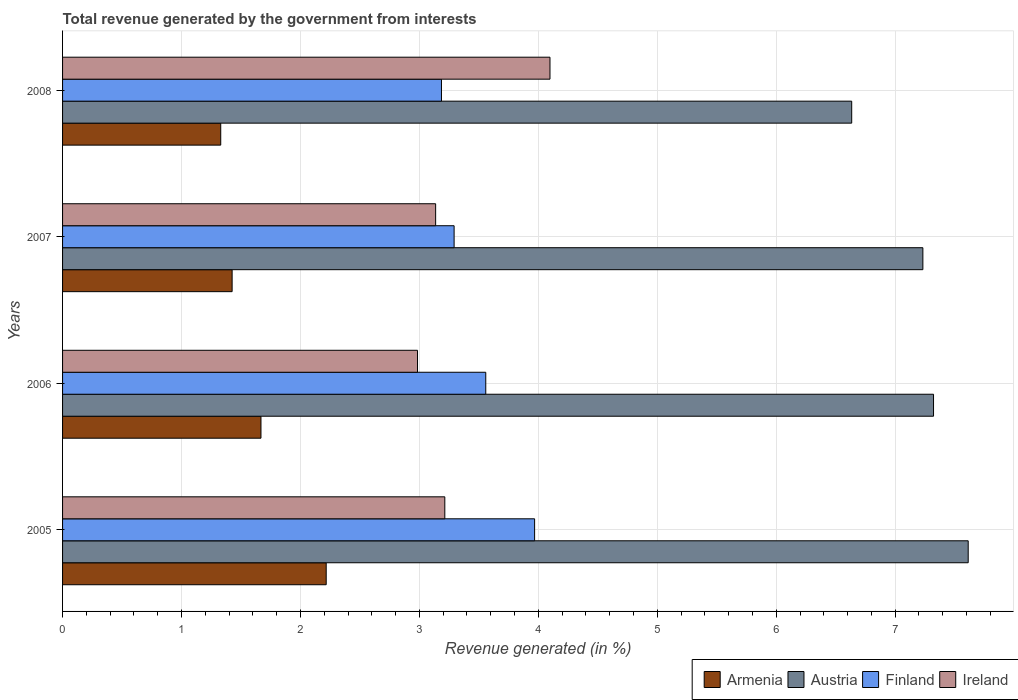How many different coloured bars are there?
Provide a succinct answer. 4. How many groups of bars are there?
Your response must be concise. 4. Are the number of bars per tick equal to the number of legend labels?
Provide a succinct answer. Yes. Are the number of bars on each tick of the Y-axis equal?
Give a very brief answer. Yes. What is the total revenue generated in Ireland in 2007?
Your response must be concise. 3.14. Across all years, what is the maximum total revenue generated in Ireland?
Keep it short and to the point. 4.1. Across all years, what is the minimum total revenue generated in Armenia?
Make the answer very short. 1.33. What is the total total revenue generated in Ireland in the graph?
Offer a very short reply. 13.43. What is the difference between the total revenue generated in Armenia in 2006 and that in 2008?
Give a very brief answer. 0.34. What is the difference between the total revenue generated in Armenia in 2005 and the total revenue generated in Finland in 2008?
Your answer should be very brief. -0.97. What is the average total revenue generated in Ireland per year?
Your response must be concise. 3.36. In the year 2007, what is the difference between the total revenue generated in Finland and total revenue generated in Ireland?
Offer a very short reply. 0.16. What is the ratio of the total revenue generated in Austria in 2006 to that in 2008?
Your response must be concise. 1.1. Is the total revenue generated in Finland in 2007 less than that in 2008?
Offer a terse response. No. Is the difference between the total revenue generated in Finland in 2005 and 2006 greater than the difference between the total revenue generated in Ireland in 2005 and 2006?
Your answer should be compact. Yes. What is the difference between the highest and the second highest total revenue generated in Austria?
Provide a short and direct response. 0.29. What is the difference between the highest and the lowest total revenue generated in Finland?
Provide a succinct answer. 0.78. In how many years, is the total revenue generated in Austria greater than the average total revenue generated in Austria taken over all years?
Keep it short and to the point. 3. What does the 3rd bar from the top in 2006 represents?
Give a very brief answer. Austria. What does the 4th bar from the bottom in 2005 represents?
Give a very brief answer. Ireland. How many years are there in the graph?
Your answer should be compact. 4. What is the difference between two consecutive major ticks on the X-axis?
Offer a terse response. 1. Does the graph contain any zero values?
Your answer should be compact. No. Where does the legend appear in the graph?
Offer a terse response. Bottom right. What is the title of the graph?
Keep it short and to the point. Total revenue generated by the government from interests. What is the label or title of the X-axis?
Keep it short and to the point. Revenue generated (in %). What is the Revenue generated (in %) in Armenia in 2005?
Your answer should be very brief. 2.22. What is the Revenue generated (in %) of Austria in 2005?
Keep it short and to the point. 7.61. What is the Revenue generated (in %) in Finland in 2005?
Keep it short and to the point. 3.97. What is the Revenue generated (in %) in Ireland in 2005?
Your response must be concise. 3.21. What is the Revenue generated (in %) in Armenia in 2006?
Offer a terse response. 1.67. What is the Revenue generated (in %) in Austria in 2006?
Give a very brief answer. 7.32. What is the Revenue generated (in %) in Finland in 2006?
Provide a short and direct response. 3.56. What is the Revenue generated (in %) of Ireland in 2006?
Ensure brevity in your answer.  2.98. What is the Revenue generated (in %) in Armenia in 2007?
Your answer should be very brief. 1.43. What is the Revenue generated (in %) in Austria in 2007?
Give a very brief answer. 7.23. What is the Revenue generated (in %) in Finland in 2007?
Keep it short and to the point. 3.29. What is the Revenue generated (in %) in Ireland in 2007?
Ensure brevity in your answer.  3.14. What is the Revenue generated (in %) in Armenia in 2008?
Your answer should be very brief. 1.33. What is the Revenue generated (in %) of Austria in 2008?
Make the answer very short. 6.63. What is the Revenue generated (in %) in Finland in 2008?
Provide a short and direct response. 3.19. What is the Revenue generated (in %) in Ireland in 2008?
Keep it short and to the point. 4.1. Across all years, what is the maximum Revenue generated (in %) of Armenia?
Provide a succinct answer. 2.22. Across all years, what is the maximum Revenue generated (in %) of Austria?
Your response must be concise. 7.61. Across all years, what is the maximum Revenue generated (in %) of Finland?
Your response must be concise. 3.97. Across all years, what is the maximum Revenue generated (in %) of Ireland?
Keep it short and to the point. 4.1. Across all years, what is the minimum Revenue generated (in %) of Armenia?
Keep it short and to the point. 1.33. Across all years, what is the minimum Revenue generated (in %) of Austria?
Ensure brevity in your answer.  6.63. Across all years, what is the minimum Revenue generated (in %) in Finland?
Offer a very short reply. 3.19. Across all years, what is the minimum Revenue generated (in %) in Ireland?
Offer a very short reply. 2.98. What is the total Revenue generated (in %) of Armenia in the graph?
Offer a very short reply. 6.64. What is the total Revenue generated (in %) in Austria in the graph?
Your response must be concise. 28.8. What is the total Revenue generated (in %) in Finland in the graph?
Keep it short and to the point. 14. What is the total Revenue generated (in %) of Ireland in the graph?
Keep it short and to the point. 13.43. What is the difference between the Revenue generated (in %) of Armenia in 2005 and that in 2006?
Keep it short and to the point. 0.55. What is the difference between the Revenue generated (in %) of Austria in 2005 and that in 2006?
Provide a succinct answer. 0.29. What is the difference between the Revenue generated (in %) of Finland in 2005 and that in 2006?
Your response must be concise. 0.41. What is the difference between the Revenue generated (in %) in Ireland in 2005 and that in 2006?
Provide a short and direct response. 0.23. What is the difference between the Revenue generated (in %) of Armenia in 2005 and that in 2007?
Offer a very short reply. 0.79. What is the difference between the Revenue generated (in %) of Austria in 2005 and that in 2007?
Provide a succinct answer. 0.38. What is the difference between the Revenue generated (in %) in Finland in 2005 and that in 2007?
Ensure brevity in your answer.  0.68. What is the difference between the Revenue generated (in %) of Ireland in 2005 and that in 2007?
Your response must be concise. 0.08. What is the difference between the Revenue generated (in %) in Armenia in 2005 and that in 2008?
Your answer should be compact. 0.89. What is the difference between the Revenue generated (in %) in Austria in 2005 and that in 2008?
Your answer should be compact. 0.98. What is the difference between the Revenue generated (in %) of Finland in 2005 and that in 2008?
Offer a very short reply. 0.78. What is the difference between the Revenue generated (in %) of Ireland in 2005 and that in 2008?
Offer a very short reply. -0.88. What is the difference between the Revenue generated (in %) of Armenia in 2006 and that in 2007?
Make the answer very short. 0.24. What is the difference between the Revenue generated (in %) of Austria in 2006 and that in 2007?
Your response must be concise. 0.09. What is the difference between the Revenue generated (in %) in Finland in 2006 and that in 2007?
Provide a succinct answer. 0.27. What is the difference between the Revenue generated (in %) in Ireland in 2006 and that in 2007?
Your answer should be very brief. -0.15. What is the difference between the Revenue generated (in %) in Armenia in 2006 and that in 2008?
Offer a terse response. 0.34. What is the difference between the Revenue generated (in %) in Austria in 2006 and that in 2008?
Your answer should be very brief. 0.69. What is the difference between the Revenue generated (in %) in Finland in 2006 and that in 2008?
Offer a very short reply. 0.37. What is the difference between the Revenue generated (in %) in Ireland in 2006 and that in 2008?
Your response must be concise. -1.11. What is the difference between the Revenue generated (in %) of Armenia in 2007 and that in 2008?
Keep it short and to the point. 0.1. What is the difference between the Revenue generated (in %) in Austria in 2007 and that in 2008?
Your answer should be compact. 0.6. What is the difference between the Revenue generated (in %) of Finland in 2007 and that in 2008?
Offer a very short reply. 0.11. What is the difference between the Revenue generated (in %) of Ireland in 2007 and that in 2008?
Ensure brevity in your answer.  -0.96. What is the difference between the Revenue generated (in %) of Armenia in 2005 and the Revenue generated (in %) of Austria in 2006?
Your response must be concise. -5.11. What is the difference between the Revenue generated (in %) of Armenia in 2005 and the Revenue generated (in %) of Finland in 2006?
Keep it short and to the point. -1.34. What is the difference between the Revenue generated (in %) in Armenia in 2005 and the Revenue generated (in %) in Ireland in 2006?
Keep it short and to the point. -0.77. What is the difference between the Revenue generated (in %) in Austria in 2005 and the Revenue generated (in %) in Finland in 2006?
Give a very brief answer. 4.06. What is the difference between the Revenue generated (in %) in Austria in 2005 and the Revenue generated (in %) in Ireland in 2006?
Your answer should be compact. 4.63. What is the difference between the Revenue generated (in %) in Finland in 2005 and the Revenue generated (in %) in Ireland in 2006?
Make the answer very short. 0.98. What is the difference between the Revenue generated (in %) of Armenia in 2005 and the Revenue generated (in %) of Austria in 2007?
Give a very brief answer. -5.02. What is the difference between the Revenue generated (in %) in Armenia in 2005 and the Revenue generated (in %) in Finland in 2007?
Provide a short and direct response. -1.08. What is the difference between the Revenue generated (in %) in Armenia in 2005 and the Revenue generated (in %) in Ireland in 2007?
Keep it short and to the point. -0.92. What is the difference between the Revenue generated (in %) of Austria in 2005 and the Revenue generated (in %) of Finland in 2007?
Keep it short and to the point. 4.32. What is the difference between the Revenue generated (in %) of Austria in 2005 and the Revenue generated (in %) of Ireland in 2007?
Your answer should be compact. 4.48. What is the difference between the Revenue generated (in %) of Finland in 2005 and the Revenue generated (in %) of Ireland in 2007?
Offer a very short reply. 0.83. What is the difference between the Revenue generated (in %) of Armenia in 2005 and the Revenue generated (in %) of Austria in 2008?
Make the answer very short. -4.42. What is the difference between the Revenue generated (in %) in Armenia in 2005 and the Revenue generated (in %) in Finland in 2008?
Your answer should be compact. -0.97. What is the difference between the Revenue generated (in %) in Armenia in 2005 and the Revenue generated (in %) in Ireland in 2008?
Offer a terse response. -1.88. What is the difference between the Revenue generated (in %) of Austria in 2005 and the Revenue generated (in %) of Finland in 2008?
Offer a terse response. 4.43. What is the difference between the Revenue generated (in %) of Austria in 2005 and the Revenue generated (in %) of Ireland in 2008?
Offer a very short reply. 3.52. What is the difference between the Revenue generated (in %) of Finland in 2005 and the Revenue generated (in %) of Ireland in 2008?
Make the answer very short. -0.13. What is the difference between the Revenue generated (in %) in Armenia in 2006 and the Revenue generated (in %) in Austria in 2007?
Keep it short and to the point. -5.57. What is the difference between the Revenue generated (in %) of Armenia in 2006 and the Revenue generated (in %) of Finland in 2007?
Your answer should be very brief. -1.62. What is the difference between the Revenue generated (in %) in Armenia in 2006 and the Revenue generated (in %) in Ireland in 2007?
Make the answer very short. -1.47. What is the difference between the Revenue generated (in %) of Austria in 2006 and the Revenue generated (in %) of Finland in 2007?
Offer a very short reply. 4.03. What is the difference between the Revenue generated (in %) in Austria in 2006 and the Revenue generated (in %) in Ireland in 2007?
Offer a very short reply. 4.19. What is the difference between the Revenue generated (in %) in Finland in 2006 and the Revenue generated (in %) in Ireland in 2007?
Your response must be concise. 0.42. What is the difference between the Revenue generated (in %) of Armenia in 2006 and the Revenue generated (in %) of Austria in 2008?
Provide a succinct answer. -4.97. What is the difference between the Revenue generated (in %) of Armenia in 2006 and the Revenue generated (in %) of Finland in 2008?
Offer a very short reply. -1.52. What is the difference between the Revenue generated (in %) in Armenia in 2006 and the Revenue generated (in %) in Ireland in 2008?
Your answer should be very brief. -2.43. What is the difference between the Revenue generated (in %) in Austria in 2006 and the Revenue generated (in %) in Finland in 2008?
Offer a terse response. 4.14. What is the difference between the Revenue generated (in %) in Austria in 2006 and the Revenue generated (in %) in Ireland in 2008?
Keep it short and to the point. 3.22. What is the difference between the Revenue generated (in %) in Finland in 2006 and the Revenue generated (in %) in Ireland in 2008?
Offer a very short reply. -0.54. What is the difference between the Revenue generated (in %) of Armenia in 2007 and the Revenue generated (in %) of Austria in 2008?
Ensure brevity in your answer.  -5.21. What is the difference between the Revenue generated (in %) of Armenia in 2007 and the Revenue generated (in %) of Finland in 2008?
Make the answer very short. -1.76. What is the difference between the Revenue generated (in %) of Armenia in 2007 and the Revenue generated (in %) of Ireland in 2008?
Provide a short and direct response. -2.67. What is the difference between the Revenue generated (in %) of Austria in 2007 and the Revenue generated (in %) of Finland in 2008?
Make the answer very short. 4.05. What is the difference between the Revenue generated (in %) of Austria in 2007 and the Revenue generated (in %) of Ireland in 2008?
Ensure brevity in your answer.  3.14. What is the difference between the Revenue generated (in %) in Finland in 2007 and the Revenue generated (in %) in Ireland in 2008?
Your response must be concise. -0.81. What is the average Revenue generated (in %) of Armenia per year?
Make the answer very short. 1.66. What is the average Revenue generated (in %) of Austria per year?
Your response must be concise. 7.2. What is the average Revenue generated (in %) of Finland per year?
Ensure brevity in your answer.  3.5. What is the average Revenue generated (in %) in Ireland per year?
Offer a very short reply. 3.36. In the year 2005, what is the difference between the Revenue generated (in %) of Armenia and Revenue generated (in %) of Austria?
Give a very brief answer. -5.4. In the year 2005, what is the difference between the Revenue generated (in %) in Armenia and Revenue generated (in %) in Finland?
Offer a very short reply. -1.75. In the year 2005, what is the difference between the Revenue generated (in %) in Armenia and Revenue generated (in %) in Ireland?
Your answer should be compact. -1. In the year 2005, what is the difference between the Revenue generated (in %) in Austria and Revenue generated (in %) in Finland?
Make the answer very short. 3.65. In the year 2005, what is the difference between the Revenue generated (in %) of Austria and Revenue generated (in %) of Ireland?
Provide a short and direct response. 4.4. In the year 2005, what is the difference between the Revenue generated (in %) of Finland and Revenue generated (in %) of Ireland?
Your response must be concise. 0.76. In the year 2006, what is the difference between the Revenue generated (in %) in Armenia and Revenue generated (in %) in Austria?
Your response must be concise. -5.65. In the year 2006, what is the difference between the Revenue generated (in %) in Armenia and Revenue generated (in %) in Finland?
Your answer should be very brief. -1.89. In the year 2006, what is the difference between the Revenue generated (in %) in Armenia and Revenue generated (in %) in Ireland?
Offer a very short reply. -1.32. In the year 2006, what is the difference between the Revenue generated (in %) of Austria and Revenue generated (in %) of Finland?
Make the answer very short. 3.76. In the year 2006, what is the difference between the Revenue generated (in %) in Austria and Revenue generated (in %) in Ireland?
Make the answer very short. 4.34. In the year 2006, what is the difference between the Revenue generated (in %) of Finland and Revenue generated (in %) of Ireland?
Provide a short and direct response. 0.57. In the year 2007, what is the difference between the Revenue generated (in %) of Armenia and Revenue generated (in %) of Austria?
Keep it short and to the point. -5.81. In the year 2007, what is the difference between the Revenue generated (in %) in Armenia and Revenue generated (in %) in Finland?
Your response must be concise. -1.87. In the year 2007, what is the difference between the Revenue generated (in %) in Armenia and Revenue generated (in %) in Ireland?
Make the answer very short. -1.71. In the year 2007, what is the difference between the Revenue generated (in %) in Austria and Revenue generated (in %) in Finland?
Ensure brevity in your answer.  3.94. In the year 2007, what is the difference between the Revenue generated (in %) in Austria and Revenue generated (in %) in Ireland?
Ensure brevity in your answer.  4.1. In the year 2007, what is the difference between the Revenue generated (in %) in Finland and Revenue generated (in %) in Ireland?
Give a very brief answer. 0.16. In the year 2008, what is the difference between the Revenue generated (in %) in Armenia and Revenue generated (in %) in Austria?
Offer a terse response. -5.3. In the year 2008, what is the difference between the Revenue generated (in %) in Armenia and Revenue generated (in %) in Finland?
Your answer should be very brief. -1.86. In the year 2008, what is the difference between the Revenue generated (in %) in Armenia and Revenue generated (in %) in Ireland?
Provide a short and direct response. -2.77. In the year 2008, what is the difference between the Revenue generated (in %) of Austria and Revenue generated (in %) of Finland?
Offer a terse response. 3.45. In the year 2008, what is the difference between the Revenue generated (in %) of Austria and Revenue generated (in %) of Ireland?
Your answer should be compact. 2.54. In the year 2008, what is the difference between the Revenue generated (in %) of Finland and Revenue generated (in %) of Ireland?
Ensure brevity in your answer.  -0.91. What is the ratio of the Revenue generated (in %) in Armenia in 2005 to that in 2006?
Your answer should be very brief. 1.33. What is the ratio of the Revenue generated (in %) in Austria in 2005 to that in 2006?
Keep it short and to the point. 1.04. What is the ratio of the Revenue generated (in %) of Finland in 2005 to that in 2006?
Your response must be concise. 1.12. What is the ratio of the Revenue generated (in %) in Armenia in 2005 to that in 2007?
Provide a short and direct response. 1.55. What is the ratio of the Revenue generated (in %) in Austria in 2005 to that in 2007?
Offer a very short reply. 1.05. What is the ratio of the Revenue generated (in %) of Finland in 2005 to that in 2007?
Offer a very short reply. 1.21. What is the ratio of the Revenue generated (in %) of Ireland in 2005 to that in 2007?
Offer a very short reply. 1.02. What is the ratio of the Revenue generated (in %) of Armenia in 2005 to that in 2008?
Keep it short and to the point. 1.67. What is the ratio of the Revenue generated (in %) in Austria in 2005 to that in 2008?
Offer a terse response. 1.15. What is the ratio of the Revenue generated (in %) of Finland in 2005 to that in 2008?
Ensure brevity in your answer.  1.25. What is the ratio of the Revenue generated (in %) in Ireland in 2005 to that in 2008?
Ensure brevity in your answer.  0.78. What is the ratio of the Revenue generated (in %) of Armenia in 2006 to that in 2007?
Ensure brevity in your answer.  1.17. What is the ratio of the Revenue generated (in %) in Austria in 2006 to that in 2007?
Offer a terse response. 1.01. What is the ratio of the Revenue generated (in %) of Finland in 2006 to that in 2007?
Offer a terse response. 1.08. What is the ratio of the Revenue generated (in %) in Ireland in 2006 to that in 2007?
Keep it short and to the point. 0.95. What is the ratio of the Revenue generated (in %) of Armenia in 2006 to that in 2008?
Make the answer very short. 1.25. What is the ratio of the Revenue generated (in %) of Austria in 2006 to that in 2008?
Keep it short and to the point. 1.1. What is the ratio of the Revenue generated (in %) in Finland in 2006 to that in 2008?
Your answer should be compact. 1.12. What is the ratio of the Revenue generated (in %) of Ireland in 2006 to that in 2008?
Ensure brevity in your answer.  0.73. What is the ratio of the Revenue generated (in %) in Armenia in 2007 to that in 2008?
Keep it short and to the point. 1.07. What is the ratio of the Revenue generated (in %) of Austria in 2007 to that in 2008?
Offer a very short reply. 1.09. What is the ratio of the Revenue generated (in %) of Finland in 2007 to that in 2008?
Make the answer very short. 1.03. What is the ratio of the Revenue generated (in %) in Ireland in 2007 to that in 2008?
Offer a very short reply. 0.77. What is the difference between the highest and the second highest Revenue generated (in %) in Armenia?
Offer a very short reply. 0.55. What is the difference between the highest and the second highest Revenue generated (in %) of Austria?
Offer a very short reply. 0.29. What is the difference between the highest and the second highest Revenue generated (in %) in Finland?
Keep it short and to the point. 0.41. What is the difference between the highest and the second highest Revenue generated (in %) of Ireland?
Keep it short and to the point. 0.88. What is the difference between the highest and the lowest Revenue generated (in %) of Armenia?
Offer a terse response. 0.89. What is the difference between the highest and the lowest Revenue generated (in %) in Austria?
Your answer should be compact. 0.98. What is the difference between the highest and the lowest Revenue generated (in %) of Finland?
Ensure brevity in your answer.  0.78. What is the difference between the highest and the lowest Revenue generated (in %) in Ireland?
Provide a short and direct response. 1.11. 